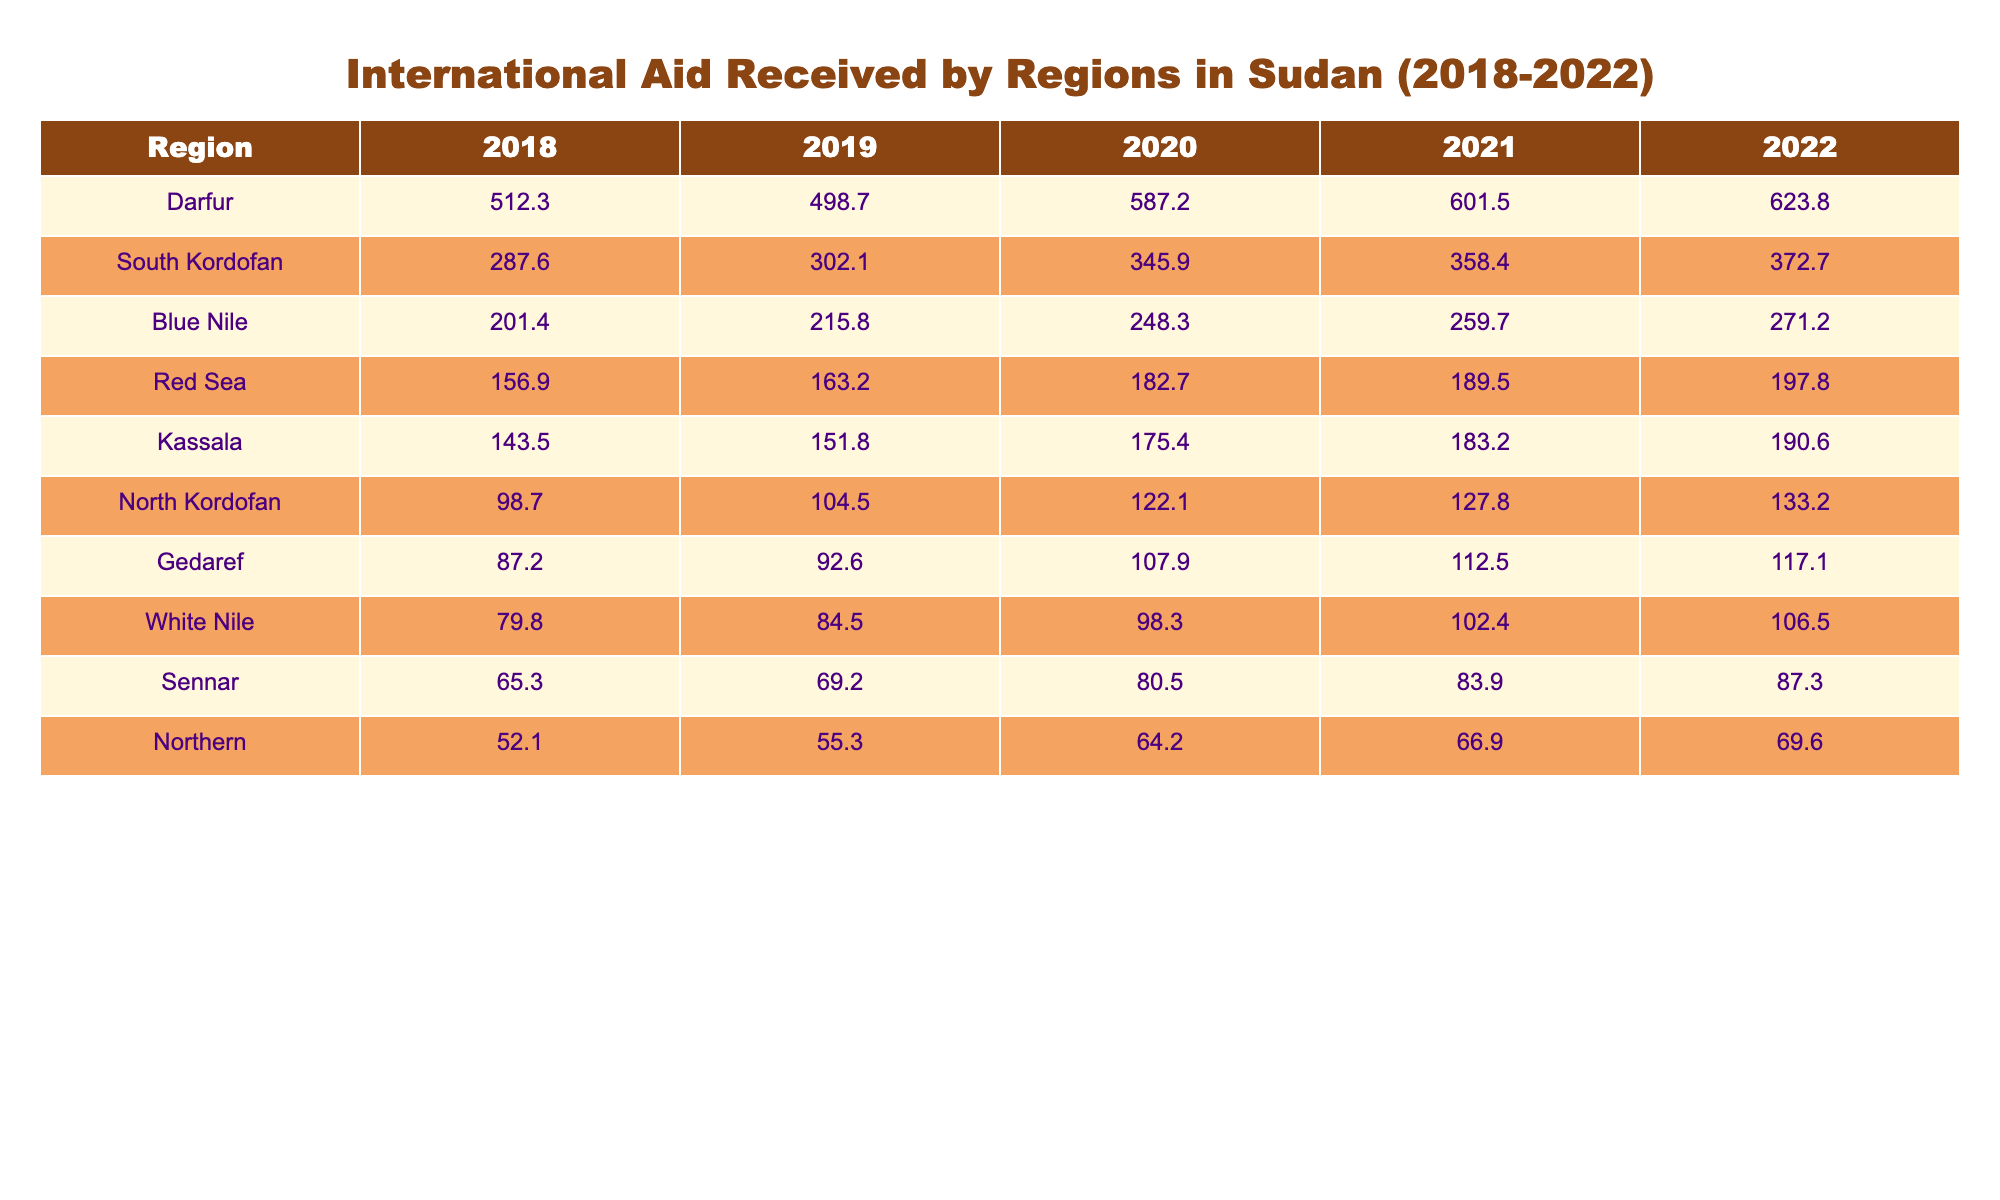What region received the highest amount of international aid in 2022? Looking at the table for the year 2022, we can see that Darfur received the highest amount of aid at 623.8 million.
Answer: Darfur Which region had the least aid in 2018? By checking the values in the table for 2018, we see that the Northern region received the least aid with 52.1 million.
Answer: Northern What is the total amount of aid received by South Kordofan from 2018 to 2022? We sum the aid amounts for South Kordofan over these years: 287.6 + 302.1 + 345.9 + 358.4 + 372.7 = 1666.7 million.
Answer: 1666.7 Is the aid received by the Blue Nile region consistently increasing each year? By examining the table, the values for years 2018 to 2022 are 201.4, 215.8, 248.3, 259.7, and 271.2, which shows an increase each year. Therefore, yes, it is consistently increasing.
Answer: Yes What is the average amount of aid received by the Red Sea region over the five years? We sum the Red Sea aid amounts for 2018 to 2022: 156.9 + 163.2 + 182.7 + 189.5 + 197.8 = 890.1, then divide by 5 to get the average: 890.1 / 5 = 178.02 million.
Answer: 178.02 Which region received more aid in 2020: Kassala or White Nile? For the year 2020, Kassala received 175.4 million and White Nile received 98.3 million; since 175.4 is greater than 98.3, Kassala received more aid.
Answer: Kassala How much more aid did Darfur receive than the Northern region in 2021? In 2021, Darfur received 601.5 million and the Northern region received 66.9 million. The difference is 601.5 - 66.9 = 534.6 million.
Answer: 534.6 What was the trend for aid given to South Kordofan from 2018 to 2022? Analyzing the numbers shows that South Kordofan aid grew steadily each year: 287.6, 302.1, 345.9, 358.4, 372.7, indicating a positive trend.
Answer: Positive trend Which two years saw the largest increase in aid for the Blue Nile region? Calculating the differences between each consecutive year shows: 2019-2018 (14.4), 2020-2019 (32.5), 2021-2020 (11.4), and 2022-2021 (11.5). The largest increase was from 2019 to 2020 (32.5 million).
Answer: 2019 to 2020 What percentage increase in aid did Gedaref experience from 2018 to 2022? To find the percentage increase, calculate: (117.1 - 87.2) / 87.2 * 100 = 34.3%.
Answer: 34.3% 